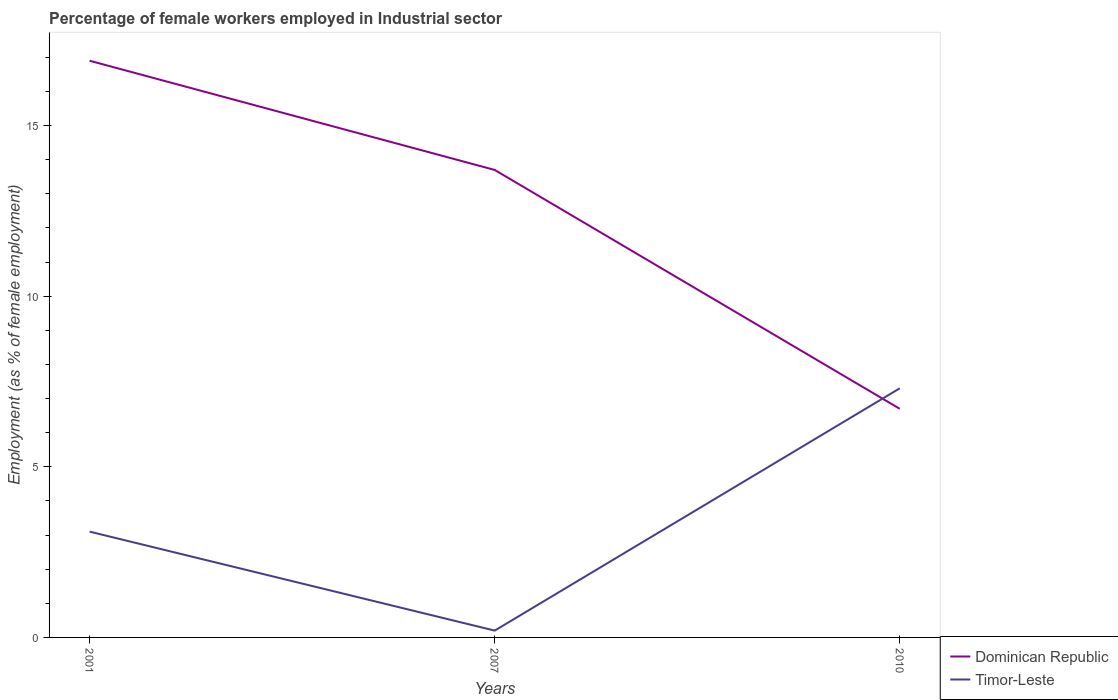Does the line corresponding to Timor-Leste intersect with the line corresponding to Dominican Republic?
Offer a terse response. Yes. Is the number of lines equal to the number of legend labels?
Offer a very short reply. Yes. Across all years, what is the maximum percentage of females employed in Industrial sector in Timor-Leste?
Your response must be concise. 0.2. In which year was the percentage of females employed in Industrial sector in Dominican Republic maximum?
Make the answer very short. 2010. What is the total percentage of females employed in Industrial sector in Timor-Leste in the graph?
Keep it short and to the point. 2.9. What is the difference between the highest and the second highest percentage of females employed in Industrial sector in Dominican Republic?
Provide a short and direct response. 10.2. Is the percentage of females employed in Industrial sector in Dominican Republic strictly greater than the percentage of females employed in Industrial sector in Timor-Leste over the years?
Your answer should be very brief. No. How many lines are there?
Offer a very short reply. 2. Are the values on the major ticks of Y-axis written in scientific E-notation?
Give a very brief answer. No. Does the graph contain any zero values?
Your response must be concise. No. Where does the legend appear in the graph?
Ensure brevity in your answer.  Bottom right. How many legend labels are there?
Provide a succinct answer. 2. How are the legend labels stacked?
Offer a very short reply. Vertical. What is the title of the graph?
Provide a succinct answer. Percentage of female workers employed in Industrial sector. What is the label or title of the Y-axis?
Keep it short and to the point. Employment (as % of female employment). What is the Employment (as % of female employment) in Dominican Republic in 2001?
Your response must be concise. 16.9. What is the Employment (as % of female employment) in Timor-Leste in 2001?
Your answer should be very brief. 3.1. What is the Employment (as % of female employment) of Dominican Republic in 2007?
Offer a very short reply. 13.7. What is the Employment (as % of female employment) in Timor-Leste in 2007?
Give a very brief answer. 0.2. What is the Employment (as % of female employment) in Dominican Republic in 2010?
Ensure brevity in your answer.  6.7. What is the Employment (as % of female employment) in Timor-Leste in 2010?
Keep it short and to the point. 7.3. Across all years, what is the maximum Employment (as % of female employment) in Dominican Republic?
Your response must be concise. 16.9. Across all years, what is the maximum Employment (as % of female employment) of Timor-Leste?
Your answer should be compact. 7.3. Across all years, what is the minimum Employment (as % of female employment) of Dominican Republic?
Make the answer very short. 6.7. Across all years, what is the minimum Employment (as % of female employment) in Timor-Leste?
Ensure brevity in your answer.  0.2. What is the total Employment (as % of female employment) in Dominican Republic in the graph?
Your answer should be compact. 37.3. What is the total Employment (as % of female employment) in Timor-Leste in the graph?
Ensure brevity in your answer.  10.6. What is the difference between the Employment (as % of female employment) of Dominican Republic in 2001 and that in 2007?
Your answer should be compact. 3.2. What is the difference between the Employment (as % of female employment) of Dominican Republic in 2001 and that in 2010?
Keep it short and to the point. 10.2. What is the difference between the Employment (as % of female employment) of Dominican Republic in 2001 and the Employment (as % of female employment) of Timor-Leste in 2007?
Provide a short and direct response. 16.7. What is the difference between the Employment (as % of female employment) of Dominican Republic in 2007 and the Employment (as % of female employment) of Timor-Leste in 2010?
Your answer should be very brief. 6.4. What is the average Employment (as % of female employment) in Dominican Republic per year?
Give a very brief answer. 12.43. What is the average Employment (as % of female employment) of Timor-Leste per year?
Your answer should be compact. 3.53. In the year 2010, what is the difference between the Employment (as % of female employment) in Dominican Republic and Employment (as % of female employment) in Timor-Leste?
Provide a short and direct response. -0.6. What is the ratio of the Employment (as % of female employment) in Dominican Republic in 2001 to that in 2007?
Provide a succinct answer. 1.23. What is the ratio of the Employment (as % of female employment) in Dominican Republic in 2001 to that in 2010?
Give a very brief answer. 2.52. What is the ratio of the Employment (as % of female employment) of Timor-Leste in 2001 to that in 2010?
Provide a succinct answer. 0.42. What is the ratio of the Employment (as % of female employment) of Dominican Republic in 2007 to that in 2010?
Offer a very short reply. 2.04. What is the ratio of the Employment (as % of female employment) of Timor-Leste in 2007 to that in 2010?
Make the answer very short. 0.03. What is the difference between the highest and the second highest Employment (as % of female employment) in Dominican Republic?
Offer a very short reply. 3.2. What is the difference between the highest and the second highest Employment (as % of female employment) in Timor-Leste?
Offer a very short reply. 4.2. What is the difference between the highest and the lowest Employment (as % of female employment) of Timor-Leste?
Ensure brevity in your answer.  7.1. 